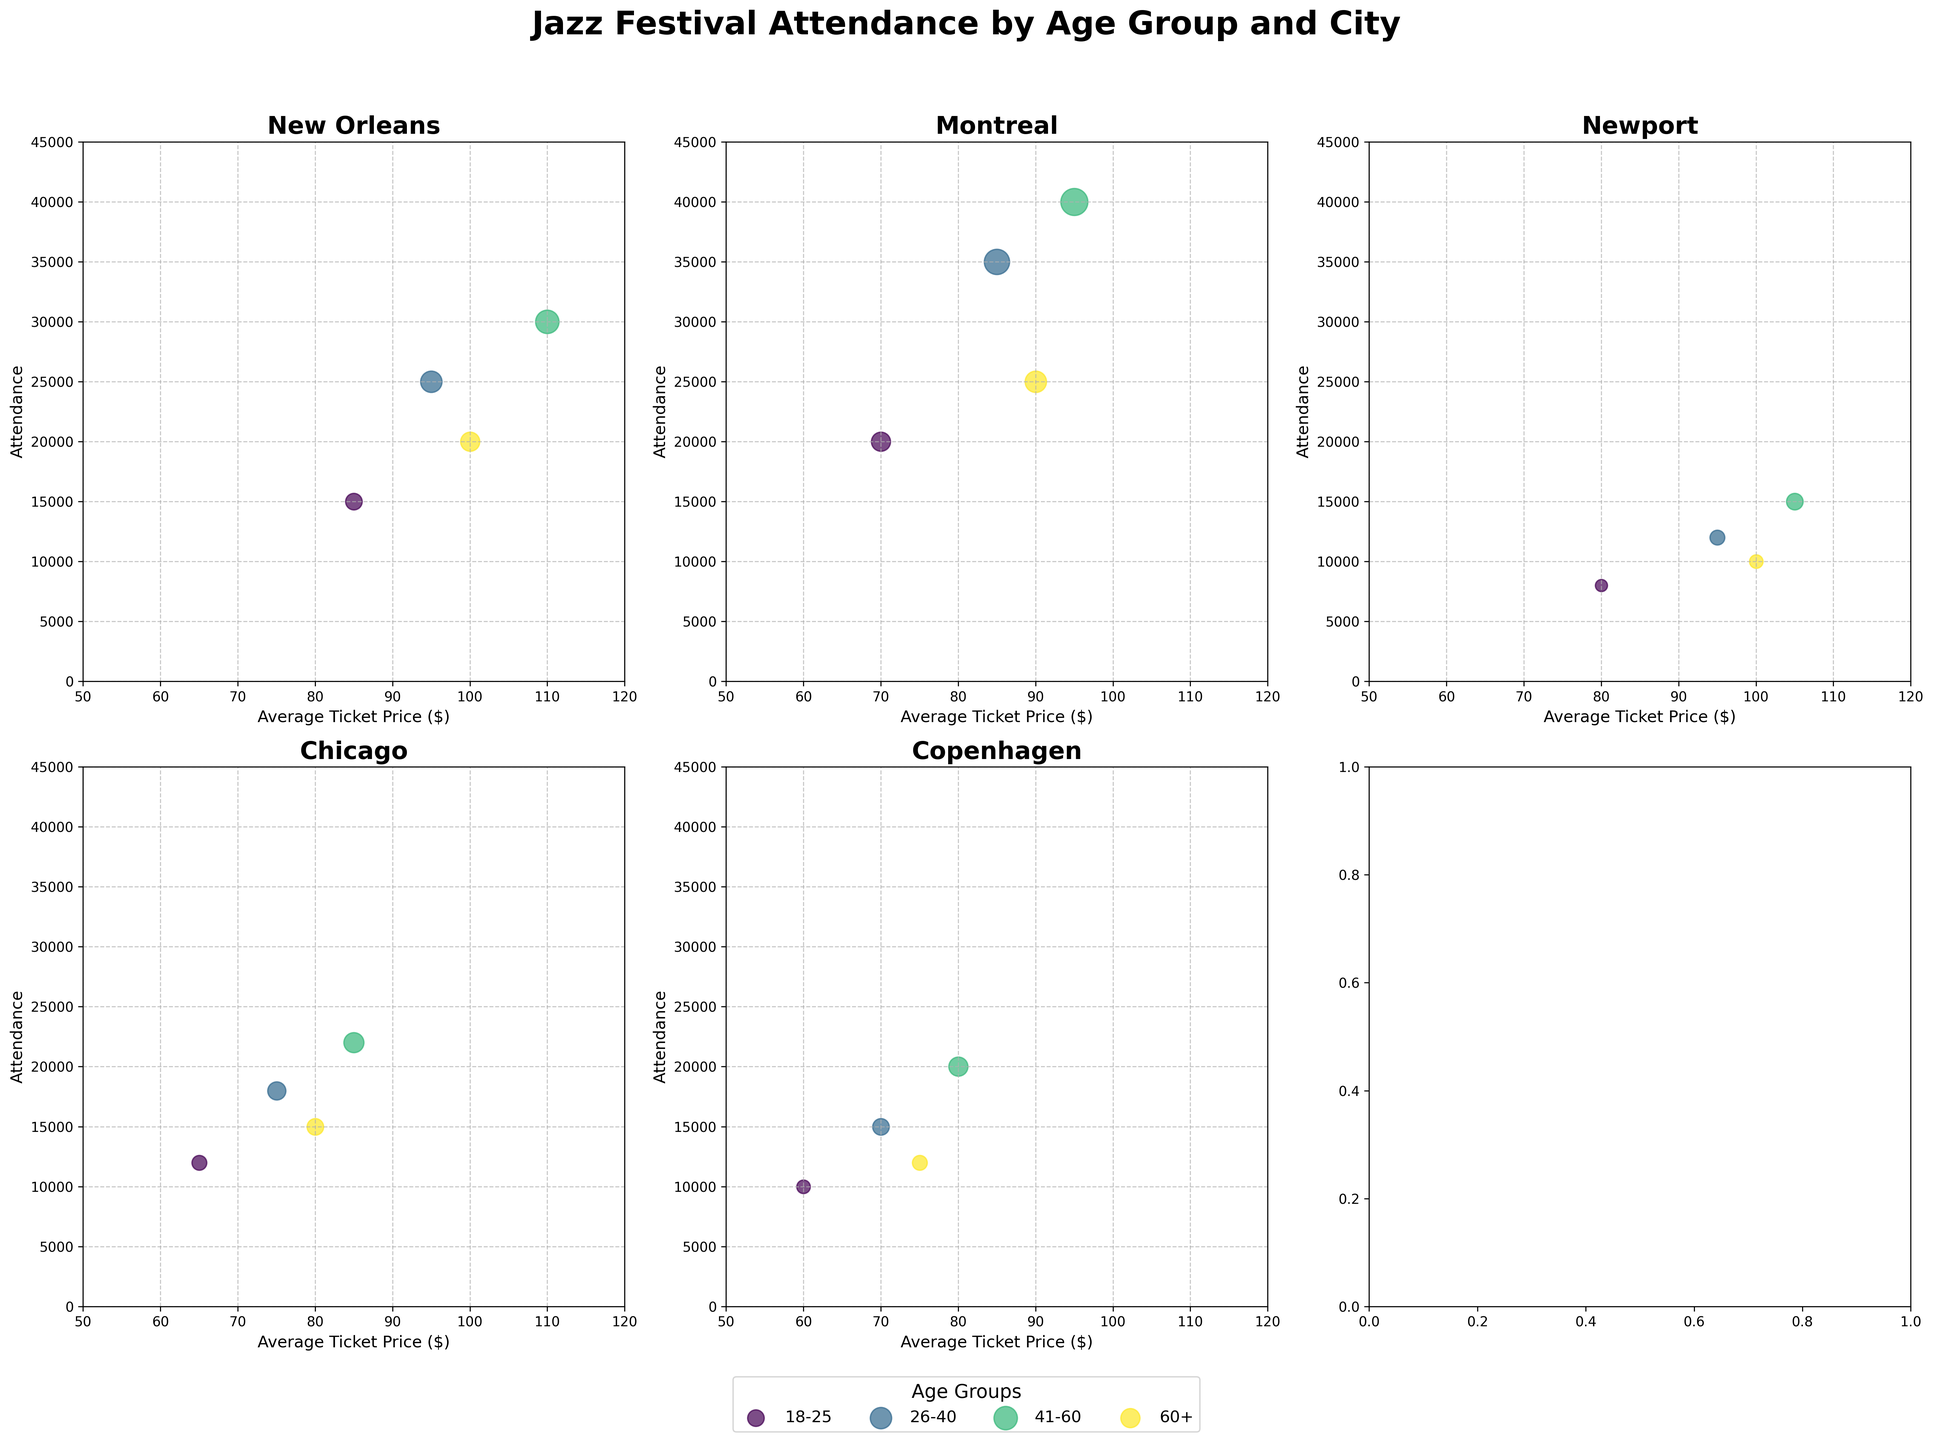What's the title of the figure? The title is located at the top of the figure and describes the overall content of the plot.
Answer: Jazz Festival Attendance by Age Group and City What does the x-axis represent? The x-axis, which is labeled at the bottom of each subplot, indicates the 'Average Ticket Price ($)'.
Answer: Average Ticket Price ($) Which city had the highest attendance for the age group 41-60? By comparing the subplots, the bubble with the highest y-coordinate value in the 41-60 age group corresponds to Montreal.
Answer: Montreal How does attendance in New Orleans compare for the age groups 18-25 and 26-40? In the New Orleans subplot, compare the sizes and positions of the bubbles representing these age groups. The 26-40 age group has a higher attendance.
Answer: The attendance is higher for the age group 26-40 Which age group in Chicago has the lowest attendance? Look at the smallest bubble in the Chicago subplot, which represents the 18-25 age group.
Answer: 18-25 What is the total attendance for the age group 60+ across all festivals? Sum the attendance numbers for the age group 60+ from each subplot: 20000 (New Orleans) + 25000 (Montreal) + 10000 (Newport) + 15000 (Chicago) + 12000 (Copenhagen) = 82000.
Answer: 82000 Which age group generally has the largest bubble size across most cities? By observing the bubbles across all subplots, the 41-60 age group consistently has the largest bubbles.
Answer: 41-60 How does the average ticket price in Copenhagen compare among age groups? Observe the x-coordinate positions of the bubbles in Copenhagen for each age group: 18-25 (~60), 26-40 (~70), 41-60 (~80), 60+ (~75).
Answer: 18-25: 60, 26-40: 70, 41-60: 80, 60+: 75 Is there a consistent trend in ticket prices across all cities for any age group? Examine the x-axis positions of bubbles for each age group across different cities. For age group 18-25, prices seem to range from around 60 to 85 consistently across cities.
Answer: Yes, the 18-25 group typically has a lower ticket price range (60-85) Which festival has the highest average ticket price based on the plot? By looking at the x-axis for the farthest right positioned bubbles, New Orleans has the highest average ticket price (~110) for the 41-60 age group.
Answer: New Orleans 